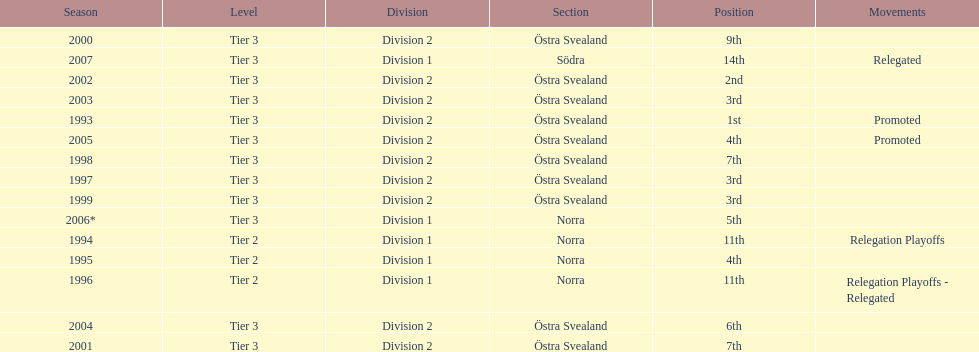What is listed under the movements column of the last season? Relegated. 